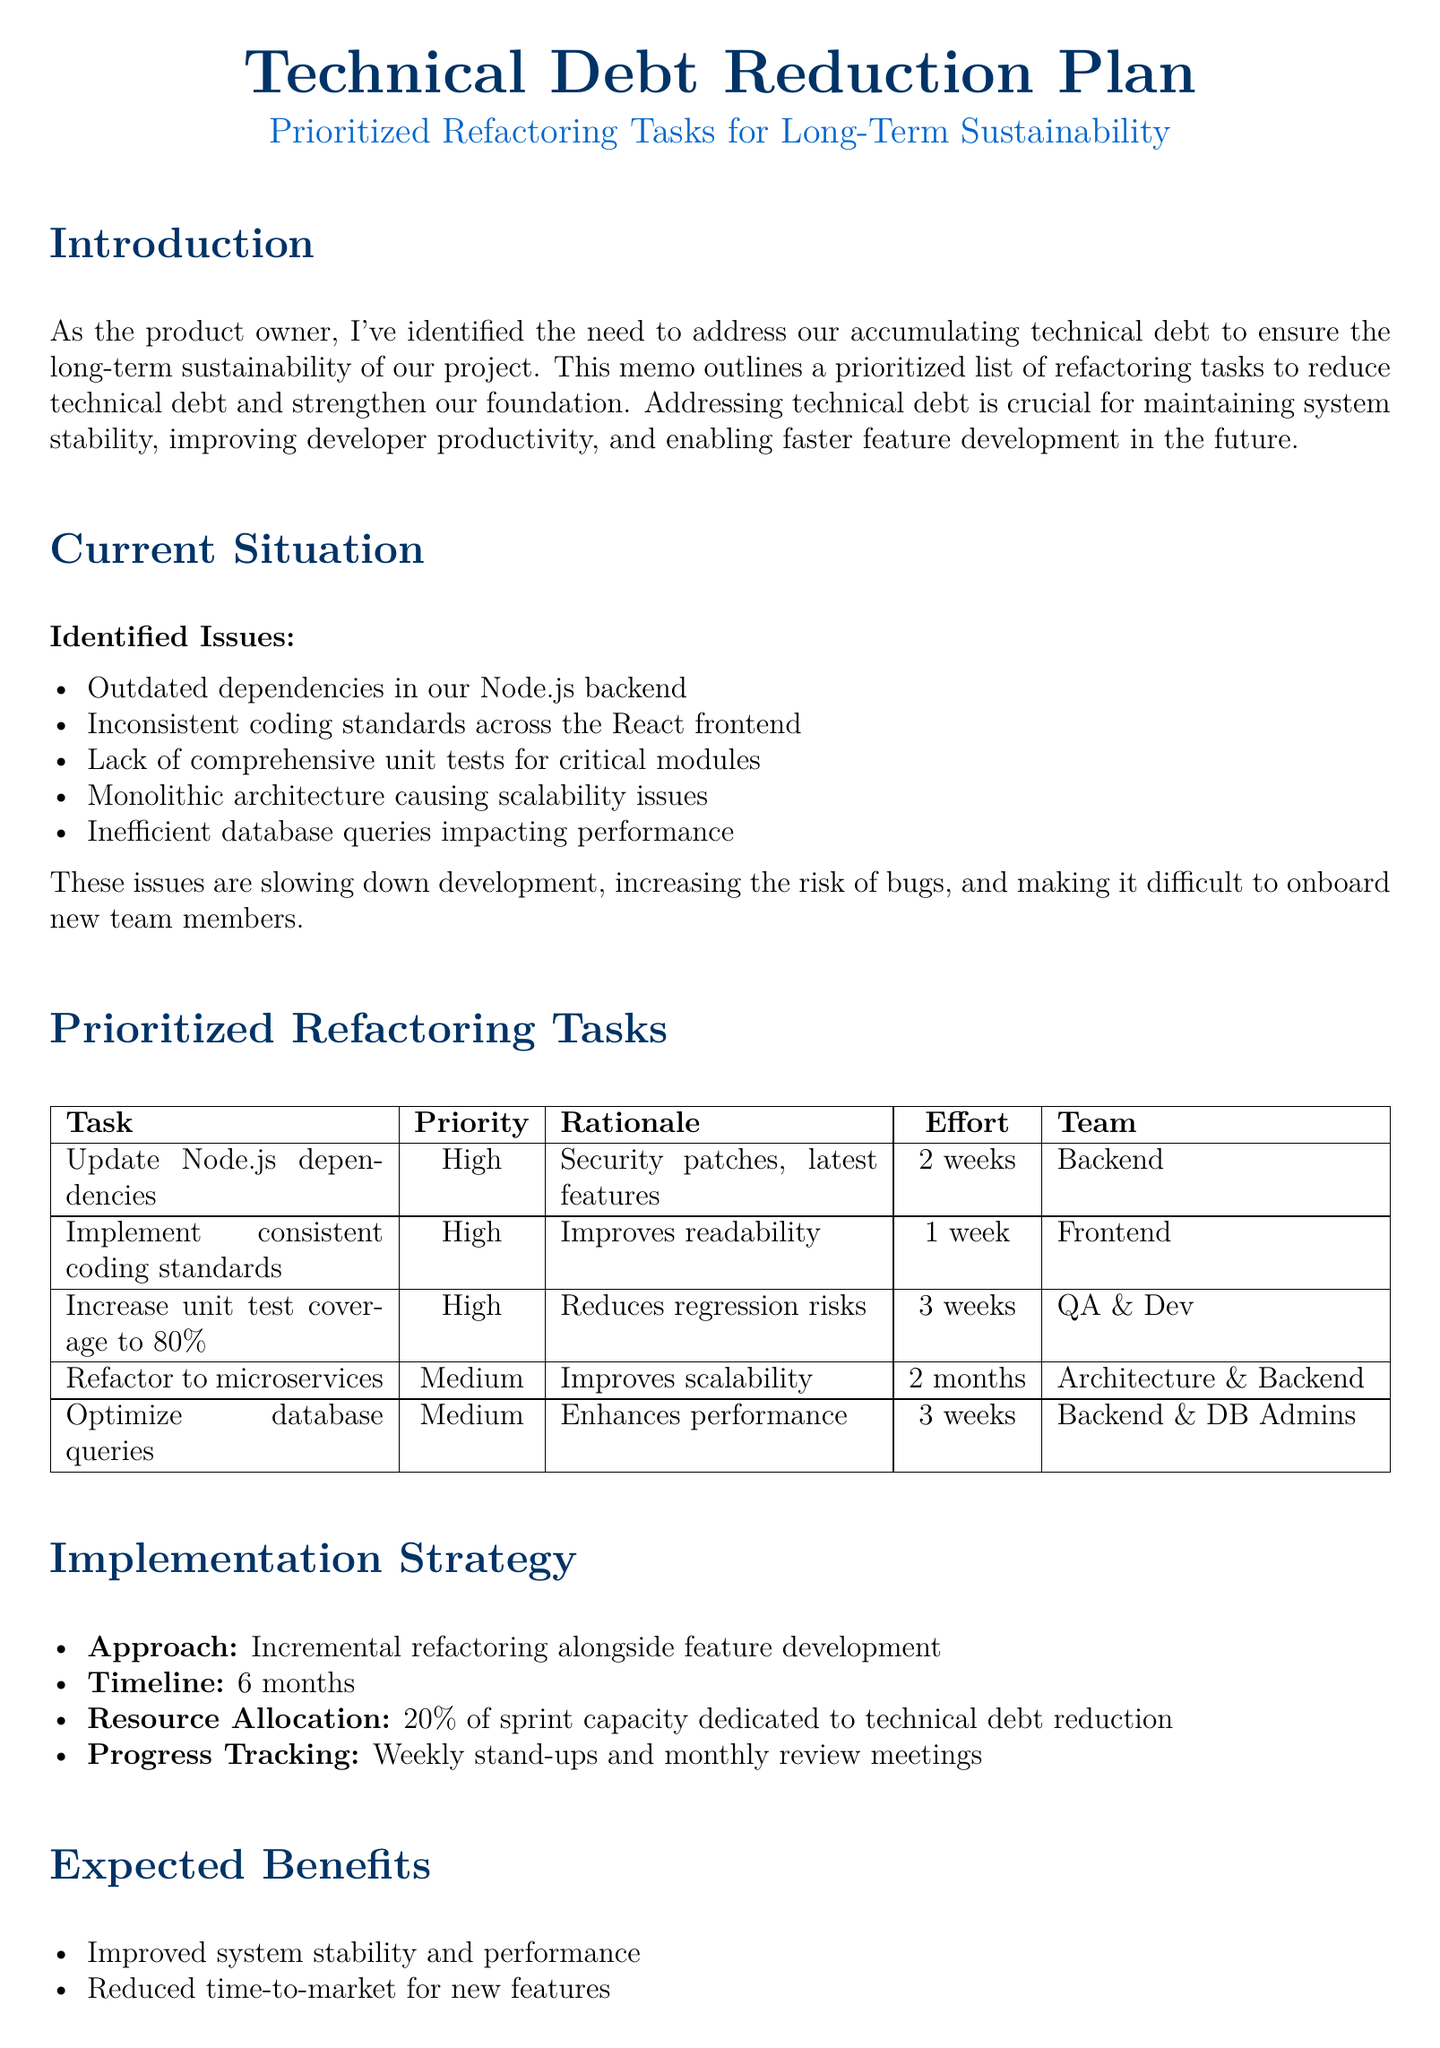what is the title of the memo? The title of the memo is stated at the beginning, emphasizing the focus on a technical debt reduction plan.
Answer: Technical Debt Reduction Plan: Prioritized Refactoring Tasks for Long-Term Sustainability how many identified issues are there? The number of identified issues is listed in the current situation section of the document.
Answer: 5 what is the priority of the task to update Node.js dependencies? The priority for this task is explicitly stated alongside the other tasks in the prioritized refactoring tasks section.
Answer: High which team is responsible for increasing unit test coverage to 80%? The responsible team is mentioned in the prioritized refactoring tasks section, indicating collaboration for this task.
Answer: QA Team in collaboration with Dev Teams what is the estimated effort for refactoring to microservices? The estimated effort for this task is provided in the prioritized refactoring tasks table.
Answer: 2 months what is the expected timeline for the implementation strategy? The timeline for the implementation is mentioned in the implementation strategy section.
Answer: 6 months what is the mitigation strategy for potential disruption to ongoing feature development? The mitigation strategy is described as a means to address one of the risks identified in the risks and mitigations section.
Answer: Careful planning and communication with stakeholders what is the estimated effort to implement consistent coding standards? The estimated effort for this task is provided in the prioritized refactoring tasks section.
Answer: 1 week 